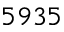Convert formula to latex. <formula><loc_0><loc_0><loc_500><loc_500>5 9 3 5</formula> 